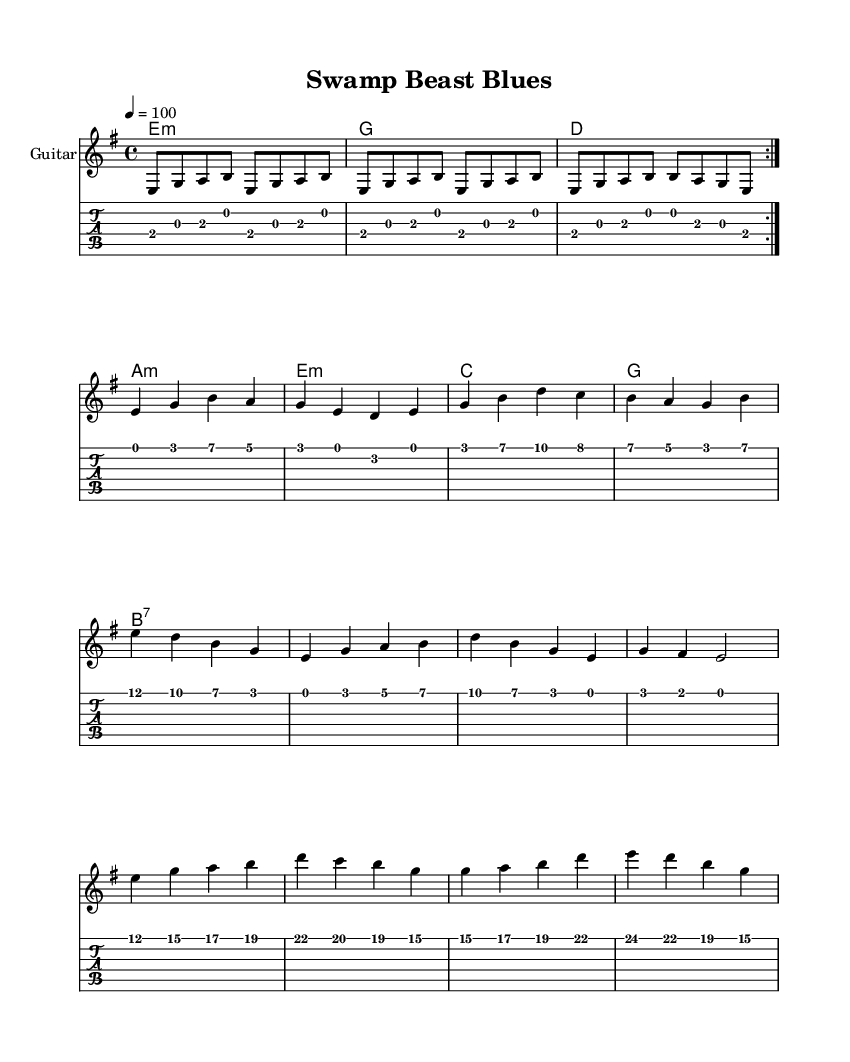What is the key signature of this music? The key signature is E minor, which has one sharp (F#).
Answer: E minor What is the time signature of this music? The time signature is 4/4, indicating four beats per measure.
Answer: 4/4 What is the tempo marking of the piece? The tempo marking is quarter note equals 100 beats per minute.
Answer: 100 How many times is the guitar riff repeated? The guitar riff is repeated two times as indicated by the "repeat volta 2" directive in the score.
Answer: 2 times What is the first chord played in this music? The first chord in the chord progression is E minor, as indicated at the start of the progression.
Answer: E minor What type of harmonica does the solo indicate? The solo is presented as a harmonica solo; however, no specific type is detailed in the sheet music.
Answer: Harmonica How many measures does the verse melody contain? The verse melody has four measures in total, based on the staff notation.
Answer: 4 measures 